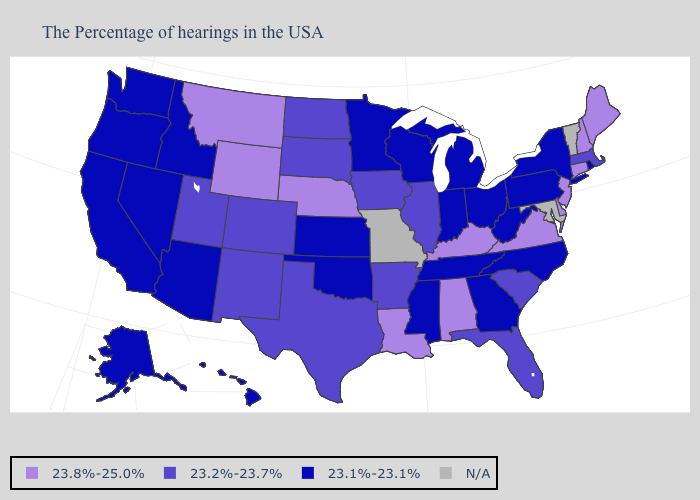What is the value of Pennsylvania?
Keep it brief. 23.1%-23.1%. Does Alabama have the highest value in the USA?
Answer briefly. Yes. What is the lowest value in the MidWest?
Answer briefly. 23.1%-23.1%. Does the first symbol in the legend represent the smallest category?
Short answer required. No. Does Wyoming have the highest value in the West?
Give a very brief answer. Yes. Name the states that have a value in the range N/A?
Quick response, please. Vermont, Maryland, Missouri. What is the value of Ohio?
Concise answer only. 23.1%-23.1%. What is the lowest value in states that border Colorado?
Be succinct. 23.1%-23.1%. What is the highest value in states that border Delaware?
Be succinct. 23.8%-25.0%. What is the value of Kentucky?
Answer briefly. 23.8%-25.0%. Name the states that have a value in the range N/A?
Give a very brief answer. Vermont, Maryland, Missouri. What is the value of Washington?
Concise answer only. 23.1%-23.1%. Does New York have the lowest value in the Northeast?
Give a very brief answer. Yes. Name the states that have a value in the range 23.1%-23.1%?
Concise answer only. Rhode Island, New York, Pennsylvania, North Carolina, West Virginia, Ohio, Georgia, Michigan, Indiana, Tennessee, Wisconsin, Mississippi, Minnesota, Kansas, Oklahoma, Arizona, Idaho, Nevada, California, Washington, Oregon, Alaska, Hawaii. 